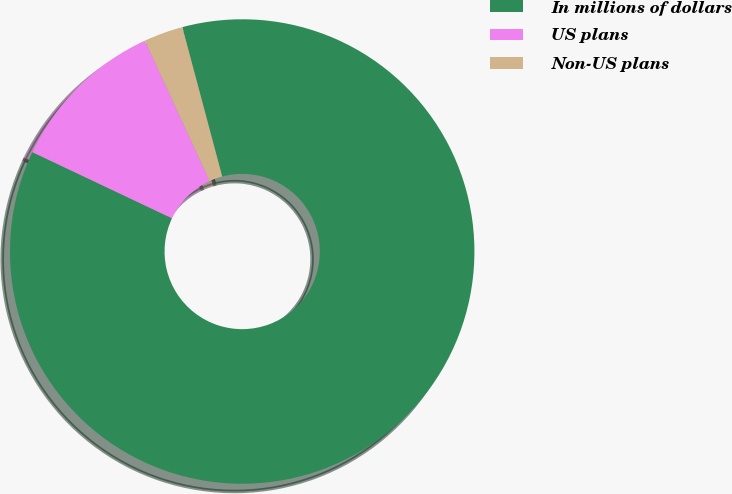Convert chart to OTSL. <chart><loc_0><loc_0><loc_500><loc_500><pie_chart><fcel>In millions of dollars<fcel>US plans<fcel>Non-US plans<nl><fcel>86.19%<fcel>11.08%<fcel>2.73%<nl></chart> 